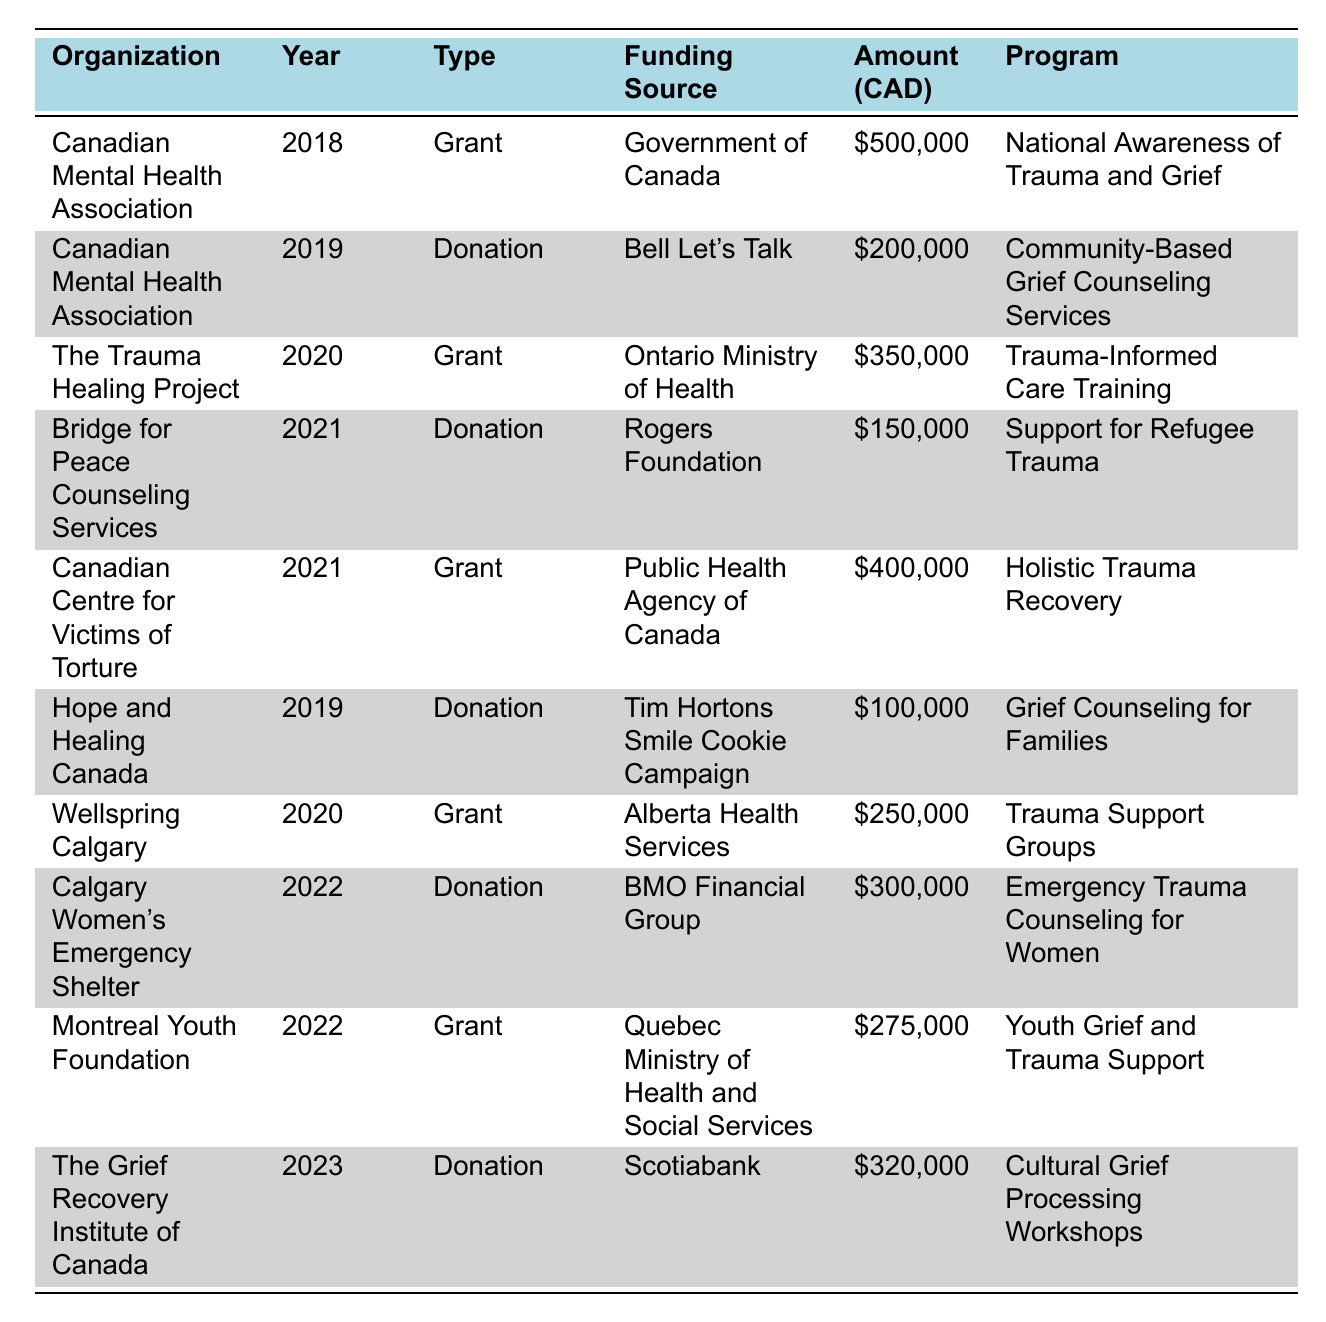What is the total amount of grants received by the Canadian Mental Health Association? In 2018, the Canadian Mental Health Association received a grant of 500,000 CAD. In 2019, it received a donation of 200,000 CAD, which does not count as a grant. So, the total amount of grants is 500,000 CAD.
Answer: 500000 CAD Which organization received funding from the Ontario Ministry of Health? The table indicates that The Trauma Healing Project received a grant from the Ontario Ministry of Health in 2020, amounting to 350,000 CAD.
Answer: The Trauma Healing Project In which year did Hope and Healing Canada receive the least amount of funding? Hope and Healing Canada received a donation of 100,000 CAD in 2019. Other donations or grants in the table are either equal to or greater than this amount. Thus, 2019 is the year with the least funding for this organization.
Answer: 2019 What is the average amount of grants received by organizations in 2021? The organizations that received grants in 2021 are the Canadian Centre for Victims of Torture (400,000 CAD) and the donation to Bridge for Peace Counseling Services is not included as it is not a grant. Therefore, to find the average grant amount for 2021, we sum 400,000 CAD and keep in mind that there is one grant: 400,000 CAD / 1 = 400,000 CAD.
Answer: 400000 CAD Did the Calgary Women's Emergency Shelter receive a donation or grant? The table shows that Calgary Women's Emergency Shelter received a donation from BMO Financial Group in 2022. Since it is categorized as a donation, the answer is yes.
Answer: Yes What is the total amount received by Montreal Youth Foundation and The Grief Recovery Institute of Canada? The Montreal Youth Foundation received a grant of 275,000 CAD in 2022, and The Grief Recovery Institute of Canada received a donation of 320,000 CAD in 2023. Combining these amounts gives 275,000 + 320,000 = 595,000 CAD.
Answer: 595000 CAD Was the total funding for trauma and grief programs higher in 2020 than in 2021? In 2020, the total funding was 250,000 CAD (Wellspring Calgary) + 350,000 CAD (The Trauma Healing Project) = 600,000 CAD. In 2021, the total was 400,000 CAD + 150,000 CAD = 550,000 CAD. Thus, 600,000 CAD is higher than 550,000 CAD.
Answer: Yes Which program received the highest funding in the table? Analyzing the funding amounts, the National Awareness of Trauma and Grief program from the Canadian Mental Health Association received 500,000 CAD, which is the highest among all listed programs.
Answer: National Awareness of Trauma and Grief How many organizations received donations over the years? By reviewing the table, we find that donations were received by Canadian Mental Health Association, Bridge for Peace Counseling Services, Hope and Healing Canada, Calgary Women's Emergency Shelter, and The Grief Recovery Institute of Canada. This totals five organizations that received donations.
Answer: 5 